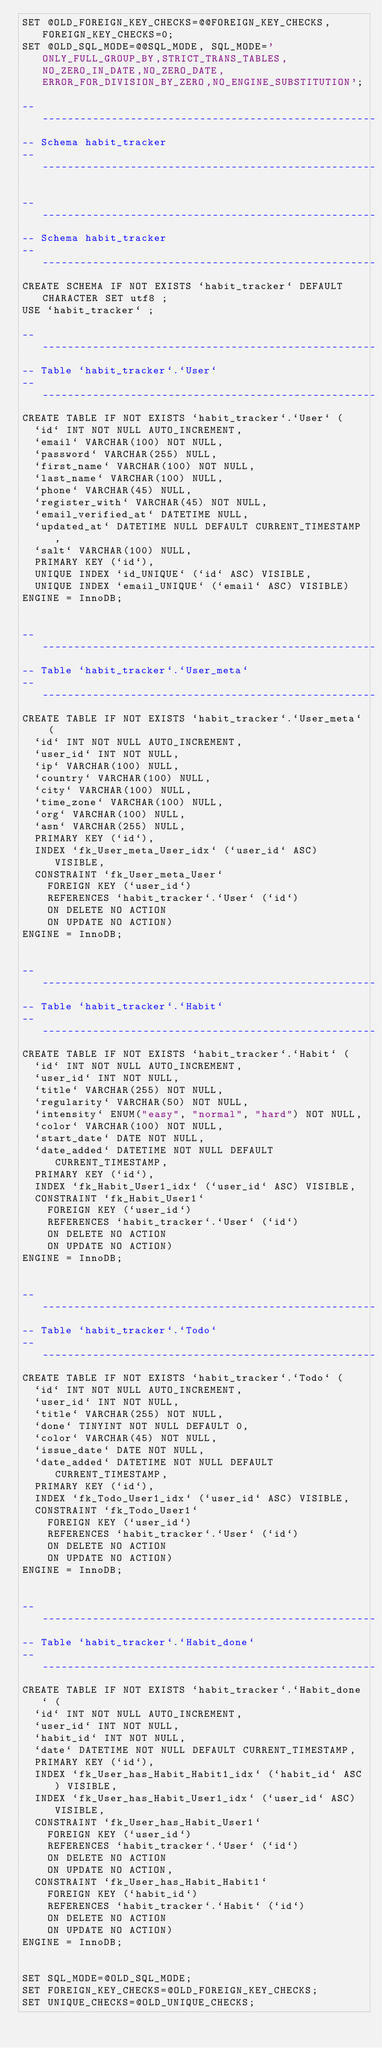<code> <loc_0><loc_0><loc_500><loc_500><_SQL_>SET @OLD_FOREIGN_KEY_CHECKS=@@FOREIGN_KEY_CHECKS, FOREIGN_KEY_CHECKS=0;
SET @OLD_SQL_MODE=@@SQL_MODE, SQL_MODE='ONLY_FULL_GROUP_BY,STRICT_TRANS_TABLES,NO_ZERO_IN_DATE,NO_ZERO_DATE,ERROR_FOR_DIVISION_BY_ZERO,NO_ENGINE_SUBSTITUTION';

-- -----------------------------------------------------
-- Schema habit_tracker
-- -----------------------------------------------------

-- -----------------------------------------------------
-- Schema habit_tracker
-- -----------------------------------------------------
CREATE SCHEMA IF NOT EXISTS `habit_tracker` DEFAULT CHARACTER SET utf8 ;
USE `habit_tracker` ;

-- -----------------------------------------------------
-- Table `habit_tracker`.`User`
-- -----------------------------------------------------
CREATE TABLE IF NOT EXISTS `habit_tracker`.`User` (
  `id` INT NOT NULL AUTO_INCREMENT,
  `email` VARCHAR(100) NOT NULL,
  `password` VARCHAR(255) NULL,
  `first_name` VARCHAR(100) NOT NULL,
  `last_name` VARCHAR(100) NULL,
  `phone` VARCHAR(45) NULL,
  `register_with` VARCHAR(45) NOT NULL,
  `email_verified_at` DATETIME NULL,
  `updated_at` DATETIME NULL DEFAULT CURRENT_TIMESTAMP,
  `salt` VARCHAR(100) NULL,
  PRIMARY KEY (`id`),
  UNIQUE INDEX `id_UNIQUE` (`id` ASC) VISIBLE,
  UNIQUE INDEX `email_UNIQUE` (`email` ASC) VISIBLE)
ENGINE = InnoDB;


-- -----------------------------------------------------
-- Table `habit_tracker`.`User_meta`
-- -----------------------------------------------------
CREATE TABLE IF NOT EXISTS `habit_tracker`.`User_meta` (
  `id` INT NOT NULL AUTO_INCREMENT,
  `user_id` INT NOT NULL,
  `ip` VARCHAR(100) NULL,
  `country` VARCHAR(100) NULL,
  `city` VARCHAR(100) NULL,
  `time_zone` VARCHAR(100) NULL,
  `org` VARCHAR(100) NULL,
  `asn` VARCHAR(255) NULL,
  PRIMARY KEY (`id`),
  INDEX `fk_User_meta_User_idx` (`user_id` ASC) VISIBLE,
  CONSTRAINT `fk_User_meta_User`
    FOREIGN KEY (`user_id`)
    REFERENCES `habit_tracker`.`User` (`id`)
    ON DELETE NO ACTION
    ON UPDATE NO ACTION)
ENGINE = InnoDB;


-- -----------------------------------------------------
-- Table `habit_tracker`.`Habit`
-- -----------------------------------------------------
CREATE TABLE IF NOT EXISTS `habit_tracker`.`Habit` (
  `id` INT NOT NULL AUTO_INCREMENT,
  `user_id` INT NOT NULL,
  `title` VARCHAR(255) NOT NULL,
  `regularity` VARCHAR(50) NOT NULL,
  `intensity` ENUM("easy", "normal", "hard") NOT NULL,
  `color` VARCHAR(100) NOT NULL,
  `start_date` DATE NOT NULL,
  `date_added` DATETIME NOT NULL DEFAULT CURRENT_TIMESTAMP,
  PRIMARY KEY (`id`),
  INDEX `fk_Habit_User1_idx` (`user_id` ASC) VISIBLE,
  CONSTRAINT `fk_Habit_User1`
    FOREIGN KEY (`user_id`)
    REFERENCES `habit_tracker`.`User` (`id`)
    ON DELETE NO ACTION
    ON UPDATE NO ACTION)
ENGINE = InnoDB;


-- -----------------------------------------------------
-- Table `habit_tracker`.`Todo`
-- -----------------------------------------------------
CREATE TABLE IF NOT EXISTS `habit_tracker`.`Todo` (
  `id` INT NOT NULL AUTO_INCREMENT,
  `user_id` INT NOT NULL,
  `title` VARCHAR(255) NOT NULL,
  `done` TINYINT NOT NULL DEFAULT 0,
  `color` VARCHAR(45) NOT NULL,
  `issue_date` DATE NOT NULL,
  `date_added` DATETIME NOT NULL DEFAULT CURRENT_TIMESTAMP,
  PRIMARY KEY (`id`),
  INDEX `fk_Todo_User1_idx` (`user_id` ASC) VISIBLE,
  CONSTRAINT `fk_Todo_User1`
    FOREIGN KEY (`user_id`)
    REFERENCES `habit_tracker`.`User` (`id`)
    ON DELETE NO ACTION
    ON UPDATE NO ACTION)
ENGINE = InnoDB;


-- -----------------------------------------------------
-- Table `habit_tracker`.`Habit_done`
-- -----------------------------------------------------
CREATE TABLE IF NOT EXISTS `habit_tracker`.`Habit_done` (
  `id` INT NOT NULL AUTO_INCREMENT,
  `user_id` INT NOT NULL,
  `habit_id` INT NOT NULL,
  `date` DATETIME NOT NULL DEFAULT CURRENT_TIMESTAMP,
  PRIMARY KEY (`id`),
  INDEX `fk_User_has_Habit_Habit1_idx` (`habit_id` ASC) VISIBLE,
  INDEX `fk_User_has_Habit_User1_idx` (`user_id` ASC) VISIBLE,
  CONSTRAINT `fk_User_has_Habit_User1`
    FOREIGN KEY (`user_id`)
    REFERENCES `habit_tracker`.`User` (`id`)
    ON DELETE NO ACTION
    ON UPDATE NO ACTION,
  CONSTRAINT `fk_User_has_Habit_Habit1`
    FOREIGN KEY (`habit_id`)
    REFERENCES `habit_tracker`.`Habit` (`id`)
    ON DELETE NO ACTION
    ON UPDATE NO ACTION)
ENGINE = InnoDB;


SET SQL_MODE=@OLD_SQL_MODE;
SET FOREIGN_KEY_CHECKS=@OLD_FOREIGN_KEY_CHECKS;
SET UNIQUE_CHECKS=@OLD_UNIQUE_CHECKS;
</code> 